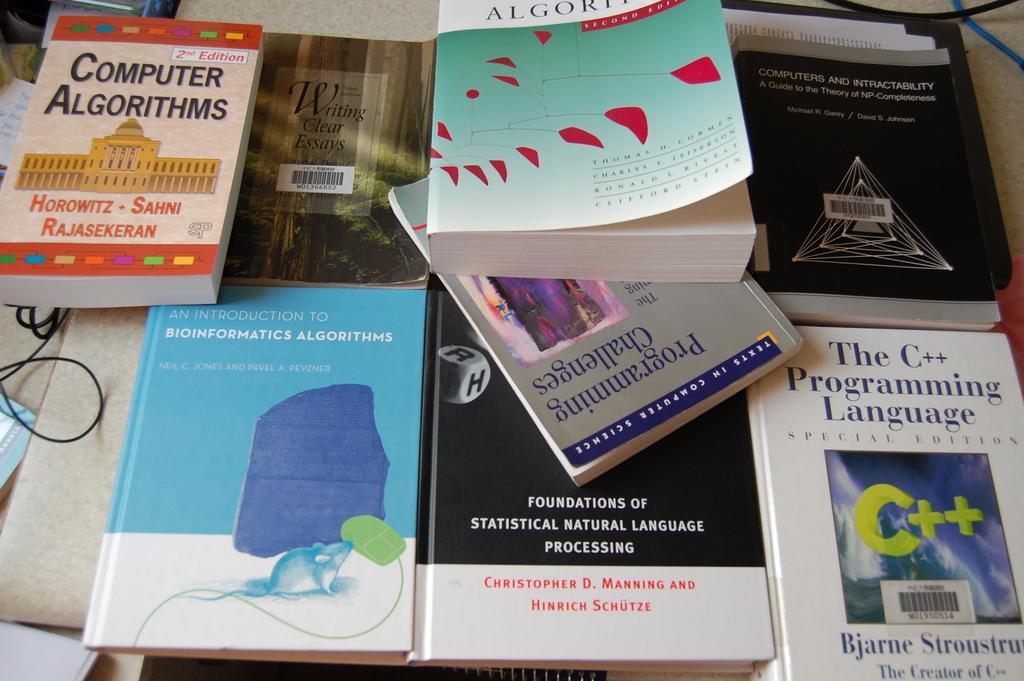Describe this image in one or two sentences. In this image we can see many books are kept on the surface. Here we can see wires. 